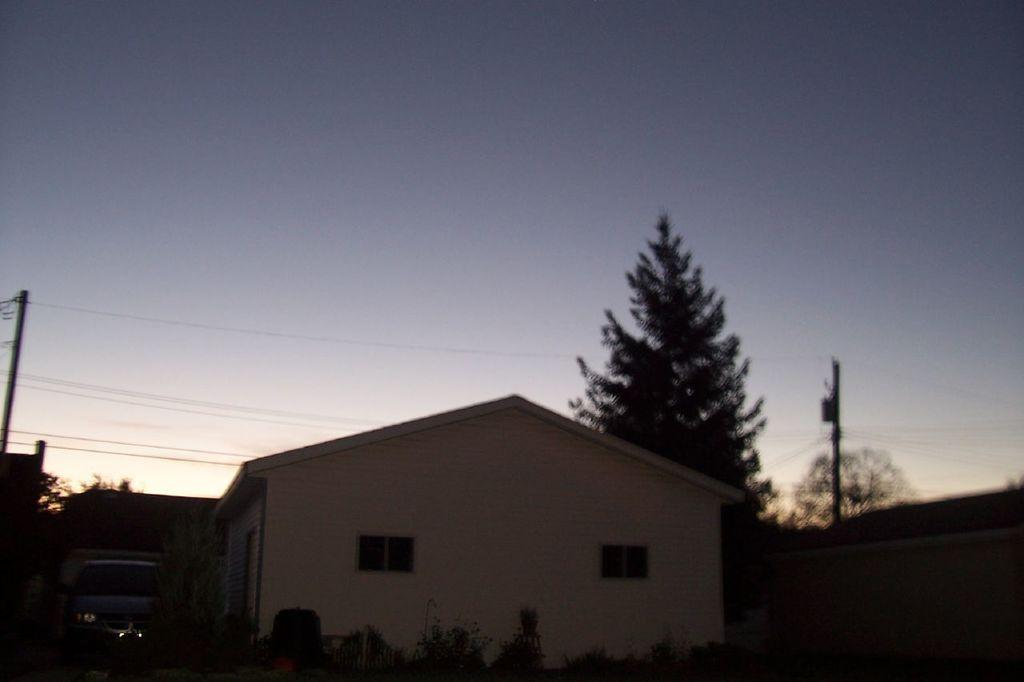What type of structure is in the image? There is a building in the image. Where is the car located in relation to the building? A car is parked on the left side of the building. What type of vegetation can be seen in the image? There are trees visible in the image. What are the vertical structures with wires in the image? Electric poles are present in the image. What is visible in the background of the image? The sky is visible in the image. What type of can does the laborer use to express their anger in the image? There is no laborer or can present in the image, nor is there any indication of anger. 